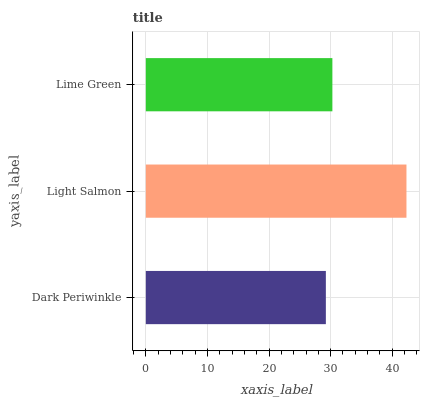Is Dark Periwinkle the minimum?
Answer yes or no. Yes. Is Light Salmon the maximum?
Answer yes or no. Yes. Is Lime Green the minimum?
Answer yes or no. No. Is Lime Green the maximum?
Answer yes or no. No. Is Light Salmon greater than Lime Green?
Answer yes or no. Yes. Is Lime Green less than Light Salmon?
Answer yes or no. Yes. Is Lime Green greater than Light Salmon?
Answer yes or no. No. Is Light Salmon less than Lime Green?
Answer yes or no. No. Is Lime Green the high median?
Answer yes or no. Yes. Is Lime Green the low median?
Answer yes or no. Yes. Is Light Salmon the high median?
Answer yes or no. No. Is Light Salmon the low median?
Answer yes or no. No. 